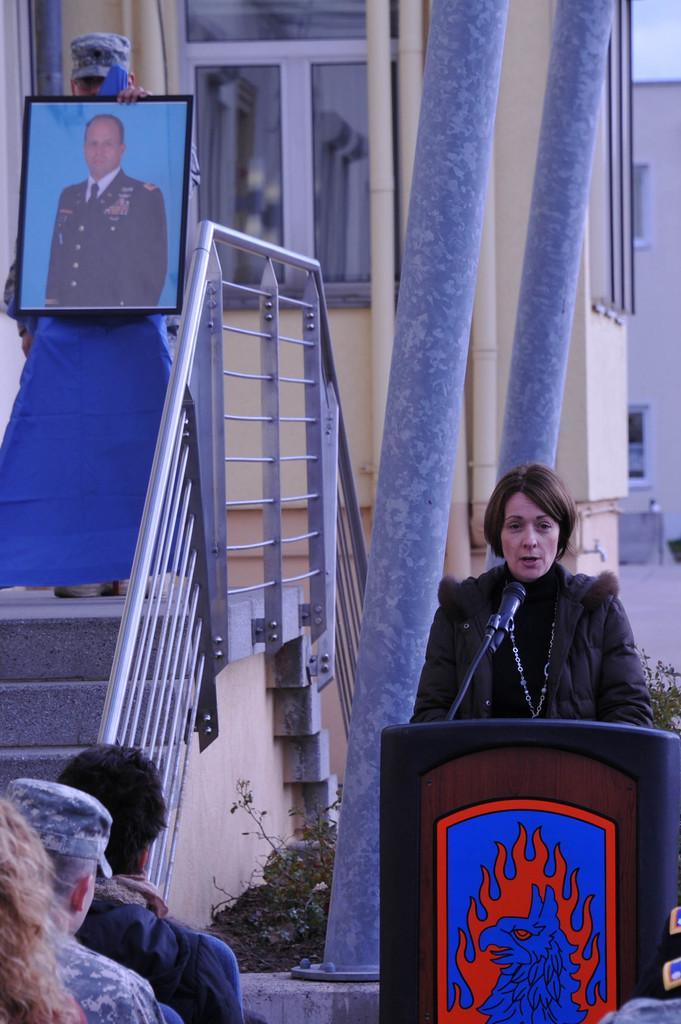How would you summarize this image in a sentence or two? In this picture there is a man who is standing near to the speech desk and she is giving speech on the mic. In the bottom left corner there are three persons were sitting on the chair. On the left there is a man who is holding a photo frame, he is standing near to the stairs and railing. In the background i can see buildings and road. In the top right corner there is a sky. At the bottom i can see the plants and gross. Beside that there are steel poles. 